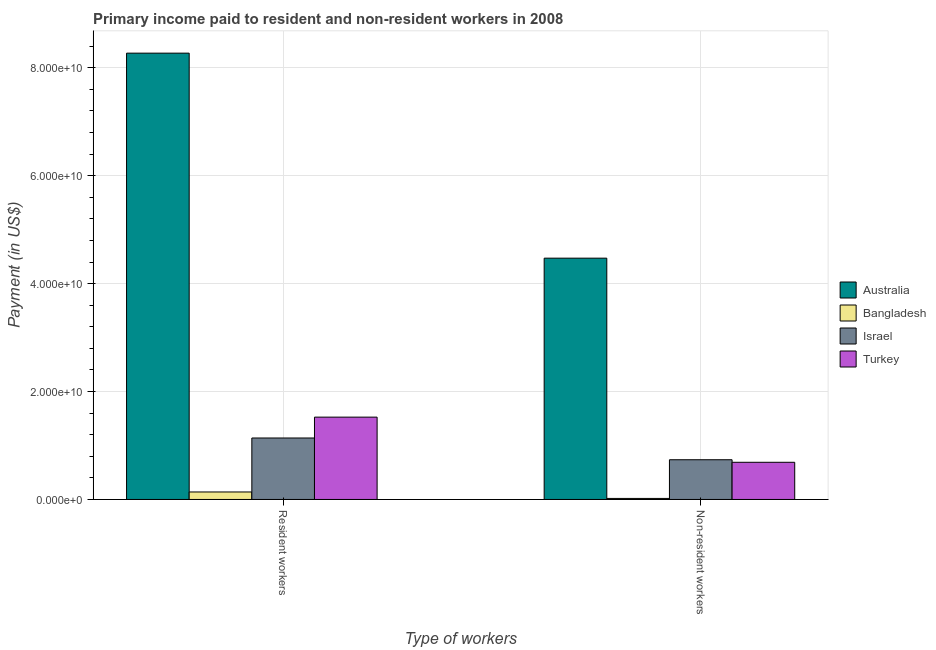Are the number of bars per tick equal to the number of legend labels?
Your answer should be very brief. Yes. What is the label of the 2nd group of bars from the left?
Your answer should be very brief. Non-resident workers. What is the payment made to resident workers in Bangladesh?
Your answer should be very brief. 1.39e+09. Across all countries, what is the maximum payment made to non-resident workers?
Make the answer very short. 4.47e+1. Across all countries, what is the minimum payment made to non-resident workers?
Give a very brief answer. 1.90e+08. In which country was the payment made to resident workers minimum?
Ensure brevity in your answer.  Bangladesh. What is the total payment made to resident workers in the graph?
Offer a terse response. 1.11e+11. What is the difference between the payment made to resident workers in Turkey and that in Bangladesh?
Provide a short and direct response. 1.39e+1. What is the difference between the payment made to resident workers in Israel and the payment made to non-resident workers in Turkey?
Provide a short and direct response. 4.50e+09. What is the average payment made to non-resident workers per country?
Give a very brief answer. 1.48e+1. What is the difference between the payment made to resident workers and payment made to non-resident workers in Bangladesh?
Keep it short and to the point. 1.20e+09. In how many countries, is the payment made to resident workers greater than 48000000000 US$?
Make the answer very short. 1. What is the ratio of the payment made to resident workers in Israel to that in Turkey?
Your response must be concise. 0.75. Is the payment made to non-resident workers in Turkey less than that in Israel?
Provide a succinct answer. Yes. In how many countries, is the payment made to resident workers greater than the average payment made to resident workers taken over all countries?
Give a very brief answer. 1. What does the 3rd bar from the left in Non-resident workers represents?
Provide a short and direct response. Israel. How many bars are there?
Offer a terse response. 8. How many countries are there in the graph?
Offer a terse response. 4. Where does the legend appear in the graph?
Your answer should be very brief. Center right. What is the title of the graph?
Your answer should be compact. Primary income paid to resident and non-resident workers in 2008. What is the label or title of the X-axis?
Provide a short and direct response. Type of workers. What is the label or title of the Y-axis?
Offer a terse response. Payment (in US$). What is the Payment (in US$) in Australia in Resident workers?
Your response must be concise. 8.27e+1. What is the Payment (in US$) of Bangladesh in Resident workers?
Ensure brevity in your answer.  1.39e+09. What is the Payment (in US$) of Israel in Resident workers?
Your answer should be compact. 1.14e+1. What is the Payment (in US$) in Turkey in Resident workers?
Make the answer very short. 1.53e+1. What is the Payment (in US$) of Australia in Non-resident workers?
Your answer should be compact. 4.47e+1. What is the Payment (in US$) of Bangladesh in Non-resident workers?
Your response must be concise. 1.90e+08. What is the Payment (in US$) in Israel in Non-resident workers?
Give a very brief answer. 7.36e+09. What is the Payment (in US$) of Turkey in Non-resident workers?
Ensure brevity in your answer.  6.89e+09. Across all Type of workers, what is the maximum Payment (in US$) of Australia?
Ensure brevity in your answer.  8.27e+1. Across all Type of workers, what is the maximum Payment (in US$) of Bangladesh?
Your answer should be compact. 1.39e+09. Across all Type of workers, what is the maximum Payment (in US$) of Israel?
Ensure brevity in your answer.  1.14e+1. Across all Type of workers, what is the maximum Payment (in US$) in Turkey?
Offer a terse response. 1.53e+1. Across all Type of workers, what is the minimum Payment (in US$) of Australia?
Your response must be concise. 4.47e+1. Across all Type of workers, what is the minimum Payment (in US$) in Bangladesh?
Provide a succinct answer. 1.90e+08. Across all Type of workers, what is the minimum Payment (in US$) of Israel?
Your response must be concise. 7.36e+09. Across all Type of workers, what is the minimum Payment (in US$) of Turkey?
Your answer should be very brief. 6.89e+09. What is the total Payment (in US$) of Australia in the graph?
Give a very brief answer. 1.27e+11. What is the total Payment (in US$) of Bangladesh in the graph?
Your answer should be very brief. 1.58e+09. What is the total Payment (in US$) of Israel in the graph?
Give a very brief answer. 1.87e+1. What is the total Payment (in US$) of Turkey in the graph?
Keep it short and to the point. 2.21e+1. What is the difference between the Payment (in US$) in Australia in Resident workers and that in Non-resident workers?
Ensure brevity in your answer.  3.80e+1. What is the difference between the Payment (in US$) in Bangladesh in Resident workers and that in Non-resident workers?
Provide a succinct answer. 1.20e+09. What is the difference between the Payment (in US$) in Israel in Resident workers and that in Non-resident workers?
Ensure brevity in your answer.  4.03e+09. What is the difference between the Payment (in US$) in Turkey in Resident workers and that in Non-resident workers?
Offer a terse response. 8.37e+09. What is the difference between the Payment (in US$) in Australia in Resident workers and the Payment (in US$) in Bangladesh in Non-resident workers?
Your answer should be compact. 8.25e+1. What is the difference between the Payment (in US$) in Australia in Resident workers and the Payment (in US$) in Israel in Non-resident workers?
Give a very brief answer. 7.53e+1. What is the difference between the Payment (in US$) in Australia in Resident workers and the Payment (in US$) in Turkey in Non-resident workers?
Make the answer very short. 7.58e+1. What is the difference between the Payment (in US$) in Bangladesh in Resident workers and the Payment (in US$) in Israel in Non-resident workers?
Your answer should be very brief. -5.97e+09. What is the difference between the Payment (in US$) of Bangladesh in Resident workers and the Payment (in US$) of Turkey in Non-resident workers?
Provide a short and direct response. -5.50e+09. What is the difference between the Payment (in US$) in Israel in Resident workers and the Payment (in US$) in Turkey in Non-resident workers?
Give a very brief answer. 4.50e+09. What is the average Payment (in US$) of Australia per Type of workers?
Make the answer very short. 6.37e+1. What is the average Payment (in US$) of Bangladesh per Type of workers?
Your response must be concise. 7.88e+08. What is the average Payment (in US$) of Israel per Type of workers?
Ensure brevity in your answer.  9.37e+09. What is the average Payment (in US$) of Turkey per Type of workers?
Your answer should be compact. 1.11e+1. What is the difference between the Payment (in US$) of Australia and Payment (in US$) of Bangladesh in Resident workers?
Provide a succinct answer. 8.13e+1. What is the difference between the Payment (in US$) of Australia and Payment (in US$) of Israel in Resident workers?
Your answer should be compact. 7.13e+1. What is the difference between the Payment (in US$) in Australia and Payment (in US$) in Turkey in Resident workers?
Make the answer very short. 6.74e+1. What is the difference between the Payment (in US$) in Bangladesh and Payment (in US$) in Israel in Resident workers?
Your answer should be compact. -1.00e+1. What is the difference between the Payment (in US$) of Bangladesh and Payment (in US$) of Turkey in Resident workers?
Ensure brevity in your answer.  -1.39e+1. What is the difference between the Payment (in US$) in Israel and Payment (in US$) in Turkey in Resident workers?
Give a very brief answer. -3.87e+09. What is the difference between the Payment (in US$) in Australia and Payment (in US$) in Bangladesh in Non-resident workers?
Give a very brief answer. 4.45e+1. What is the difference between the Payment (in US$) of Australia and Payment (in US$) of Israel in Non-resident workers?
Provide a short and direct response. 3.74e+1. What is the difference between the Payment (in US$) of Australia and Payment (in US$) of Turkey in Non-resident workers?
Your answer should be compact. 3.78e+1. What is the difference between the Payment (in US$) of Bangladesh and Payment (in US$) of Israel in Non-resident workers?
Your answer should be compact. -7.17e+09. What is the difference between the Payment (in US$) of Bangladesh and Payment (in US$) of Turkey in Non-resident workers?
Provide a short and direct response. -6.70e+09. What is the difference between the Payment (in US$) of Israel and Payment (in US$) of Turkey in Non-resident workers?
Your answer should be compact. 4.70e+08. What is the ratio of the Payment (in US$) in Australia in Resident workers to that in Non-resident workers?
Your response must be concise. 1.85. What is the ratio of the Payment (in US$) in Bangladesh in Resident workers to that in Non-resident workers?
Ensure brevity in your answer.  7.29. What is the ratio of the Payment (in US$) of Israel in Resident workers to that in Non-resident workers?
Give a very brief answer. 1.55. What is the ratio of the Payment (in US$) of Turkey in Resident workers to that in Non-resident workers?
Offer a terse response. 2.21. What is the difference between the highest and the second highest Payment (in US$) of Australia?
Provide a succinct answer. 3.80e+1. What is the difference between the highest and the second highest Payment (in US$) in Bangladesh?
Make the answer very short. 1.20e+09. What is the difference between the highest and the second highest Payment (in US$) of Israel?
Your answer should be very brief. 4.03e+09. What is the difference between the highest and the second highest Payment (in US$) in Turkey?
Your response must be concise. 8.37e+09. What is the difference between the highest and the lowest Payment (in US$) of Australia?
Make the answer very short. 3.80e+1. What is the difference between the highest and the lowest Payment (in US$) in Bangladesh?
Provide a succinct answer. 1.20e+09. What is the difference between the highest and the lowest Payment (in US$) of Israel?
Offer a very short reply. 4.03e+09. What is the difference between the highest and the lowest Payment (in US$) of Turkey?
Keep it short and to the point. 8.37e+09. 